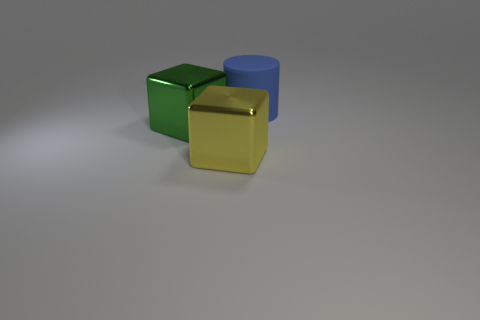Are there fewer large cubes to the right of the large green metal block than cubes in front of the blue thing?
Keep it short and to the point. Yes. There is a big object that is both behind the yellow cube and on the left side of the rubber object; what color is it?
Your response must be concise. Green. There is a rubber cylinder; is its size the same as the block on the right side of the green cube?
Offer a terse response. Yes. The metal object in front of the large green block has what shape?
Provide a short and direct response. Cube. Is there anything else that has the same material as the blue thing?
Give a very brief answer. No. Is the number of large yellow metal things that are in front of the large yellow block greater than the number of gray matte blocks?
Keep it short and to the point. No. There is a large metallic object that is in front of the big metal object that is behind the yellow metal thing; how many shiny blocks are behind it?
Offer a terse response. 1. There is a metallic block that is on the right side of the large green thing; is its size the same as the cube that is behind the yellow metal thing?
Offer a very short reply. Yes. What material is the large block left of the big thing that is in front of the big green metal thing?
Offer a very short reply. Metal. What number of objects are either large metal blocks on the right side of the green metallic cube or large green metal objects?
Your answer should be compact. 2. 